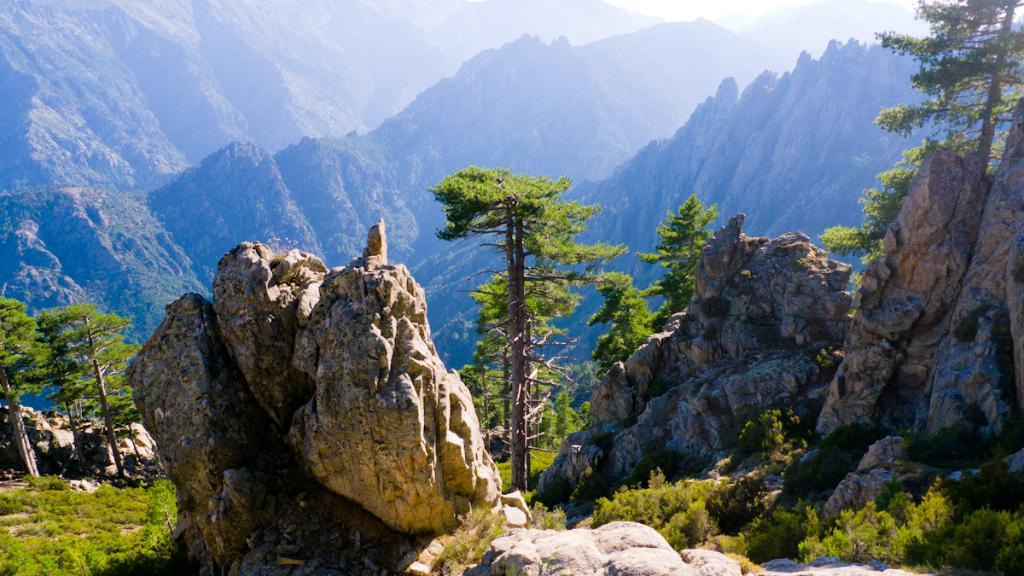What type of view is shown in the image? The image is an outside view. What can be seen at the bottom of the image? There are rocks and trees at the bottom of the image. What else is present in the image besides rocks and trees? There are many plants in the image. What can be seen in the distance in the image? There are mountains visible in the background of the image. What year is depicted in the image? The image does not depict a specific year; it is a photograph of a natural landscape. 